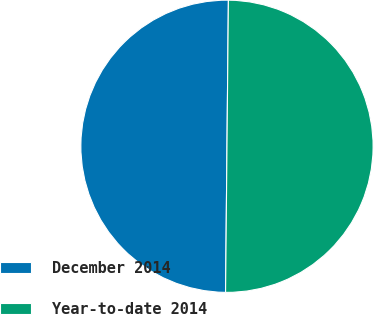<chart> <loc_0><loc_0><loc_500><loc_500><pie_chart><fcel>December 2014<fcel>Year-to-date 2014<nl><fcel>50.0%<fcel>50.0%<nl></chart> 